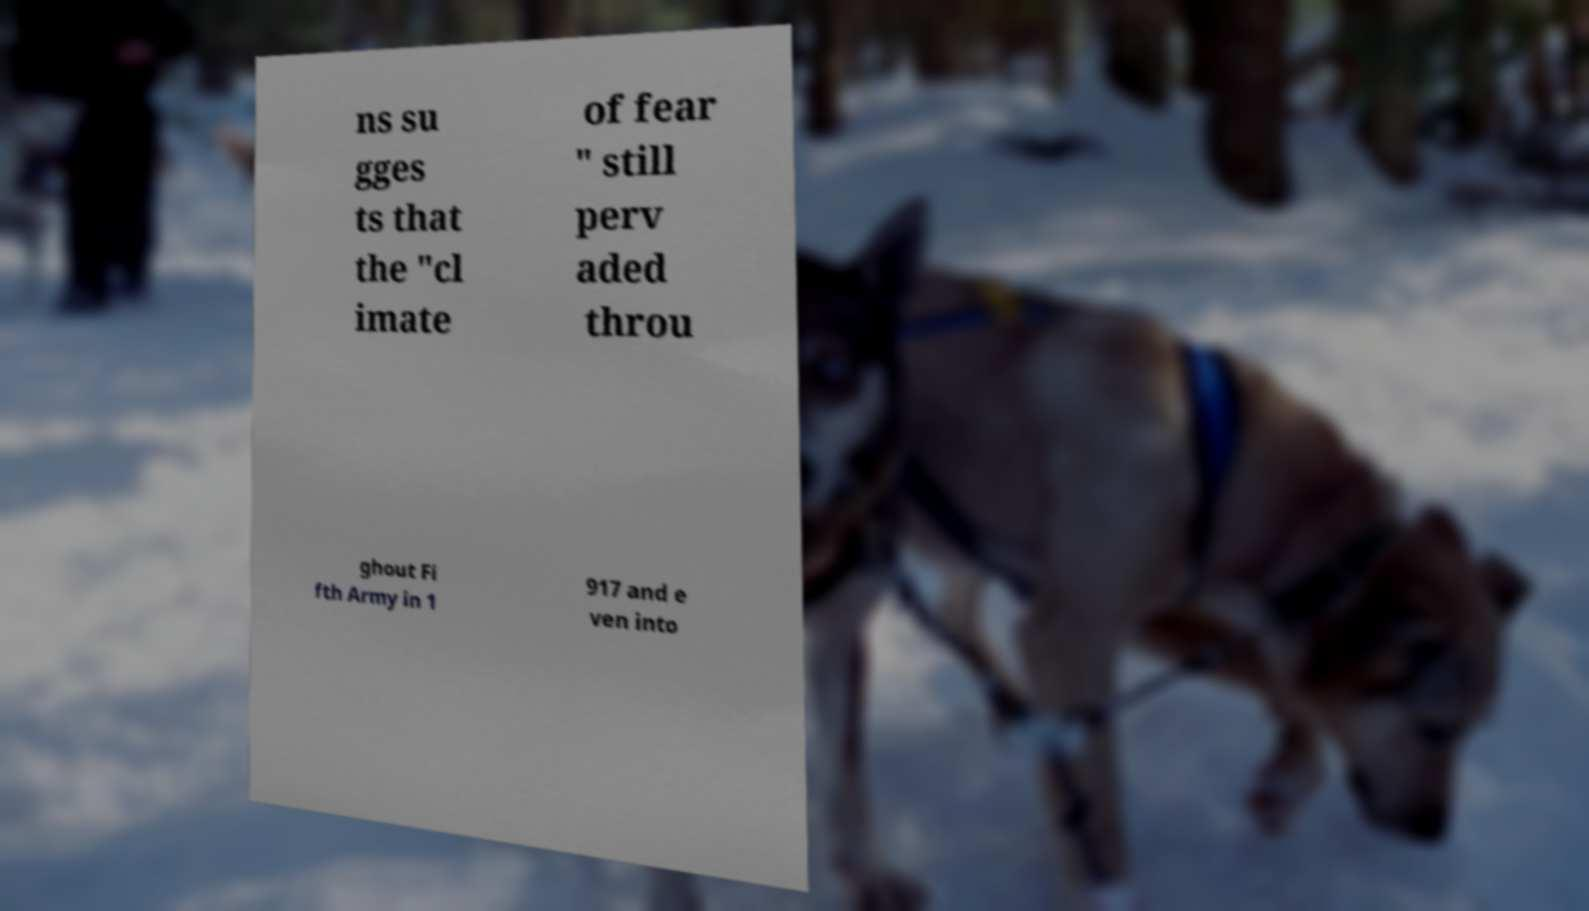What messages or text are displayed in this image? I need them in a readable, typed format. ns su gges ts that the "cl imate of fear " still perv aded throu ghout Fi fth Army in 1 917 and e ven into 